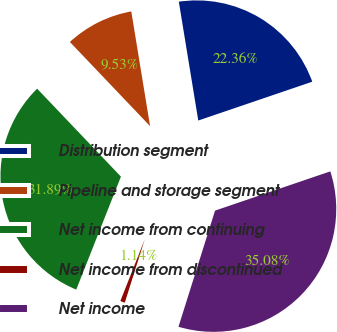Convert chart. <chart><loc_0><loc_0><loc_500><loc_500><pie_chart><fcel>Distribution segment<fcel>Pipeline and storage segment<fcel>Net income from continuing<fcel>Net income from discontinued<fcel>Net income<nl><fcel>22.36%<fcel>9.53%<fcel>31.89%<fcel>1.14%<fcel>35.08%<nl></chart> 